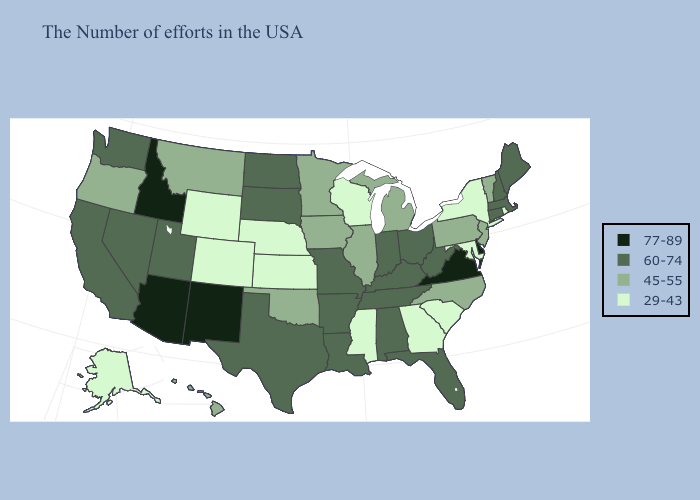How many symbols are there in the legend?
Quick response, please. 4. What is the lowest value in the USA?
Answer briefly. 29-43. What is the highest value in the USA?
Be succinct. 77-89. What is the highest value in states that border Florida?
Concise answer only. 60-74. Name the states that have a value in the range 77-89?
Quick response, please. Delaware, Virginia, New Mexico, Arizona, Idaho. What is the highest value in states that border Alabama?
Answer briefly. 60-74. Is the legend a continuous bar?
Give a very brief answer. No. What is the value of Oklahoma?
Quick response, please. 45-55. Does New York have the lowest value in the Northeast?
Keep it brief. Yes. Does Oklahoma have a lower value than Kentucky?
Write a very short answer. Yes. Name the states that have a value in the range 77-89?
Quick response, please. Delaware, Virginia, New Mexico, Arizona, Idaho. Does Kentucky have the same value as Arkansas?
Answer briefly. Yes. What is the highest value in the MidWest ?
Be succinct. 60-74. Which states have the highest value in the USA?
Be succinct. Delaware, Virginia, New Mexico, Arizona, Idaho. Among the states that border West Virginia , which have the lowest value?
Keep it brief. Maryland. 